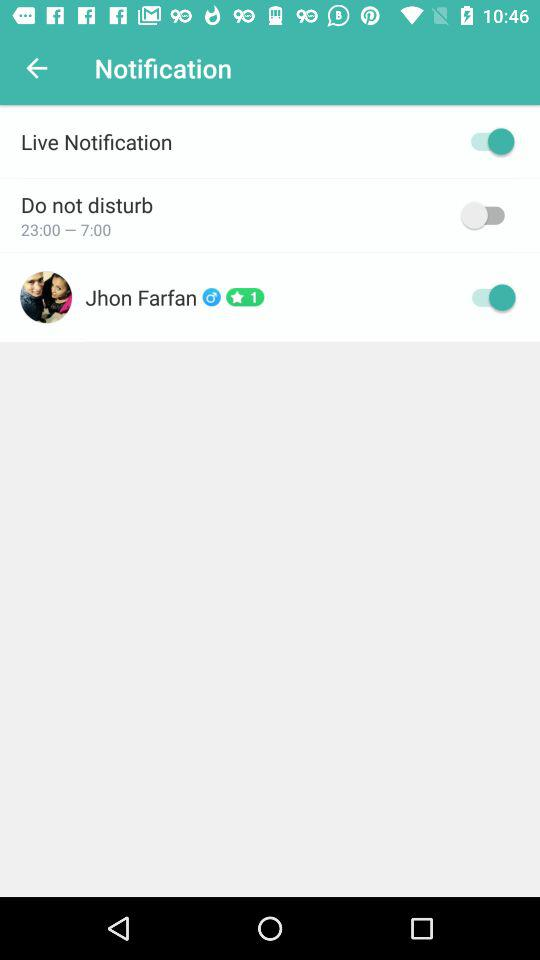What is the rating of the profile? The rating is 1 star. 